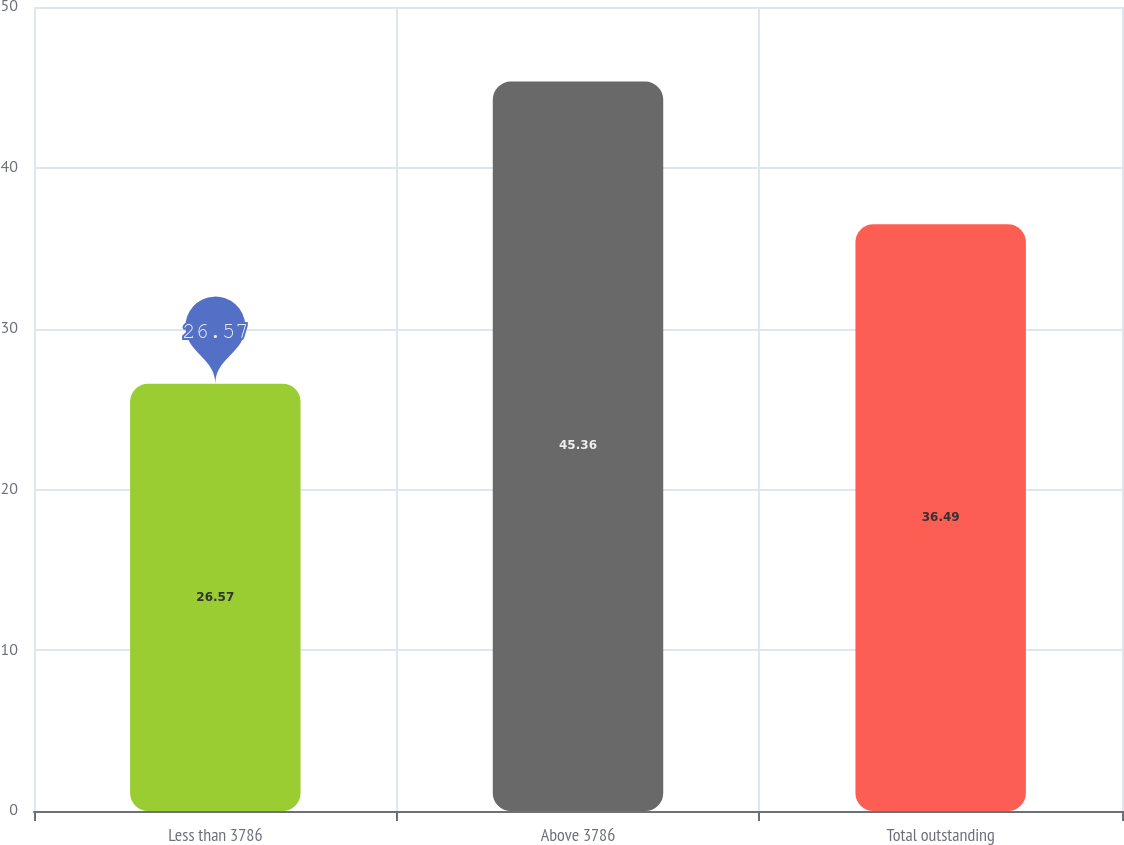Convert chart. <chart><loc_0><loc_0><loc_500><loc_500><bar_chart><fcel>Less than 3786<fcel>Above 3786<fcel>Total outstanding<nl><fcel>26.57<fcel>45.36<fcel>36.49<nl></chart> 